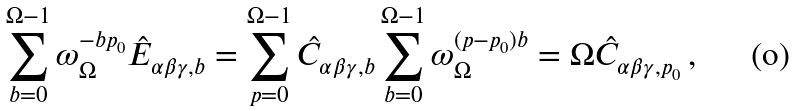Convert formula to latex. <formula><loc_0><loc_0><loc_500><loc_500>\sum _ { b = 0 } ^ { \Omega - 1 } \omega _ { \Omega } ^ { - b p _ { 0 } } \hat { E } _ { \alpha \beta \gamma , b } = \sum _ { p = 0 } ^ { \Omega - 1 } \hat { C } _ { \alpha \beta \gamma , b } \sum _ { b = 0 } ^ { \Omega - 1 } \omega _ { \Omega } ^ { ( p - p _ { 0 } ) b } = \Omega \hat { C } _ { \alpha \beta \gamma , p _ { 0 } } \, ,</formula> 